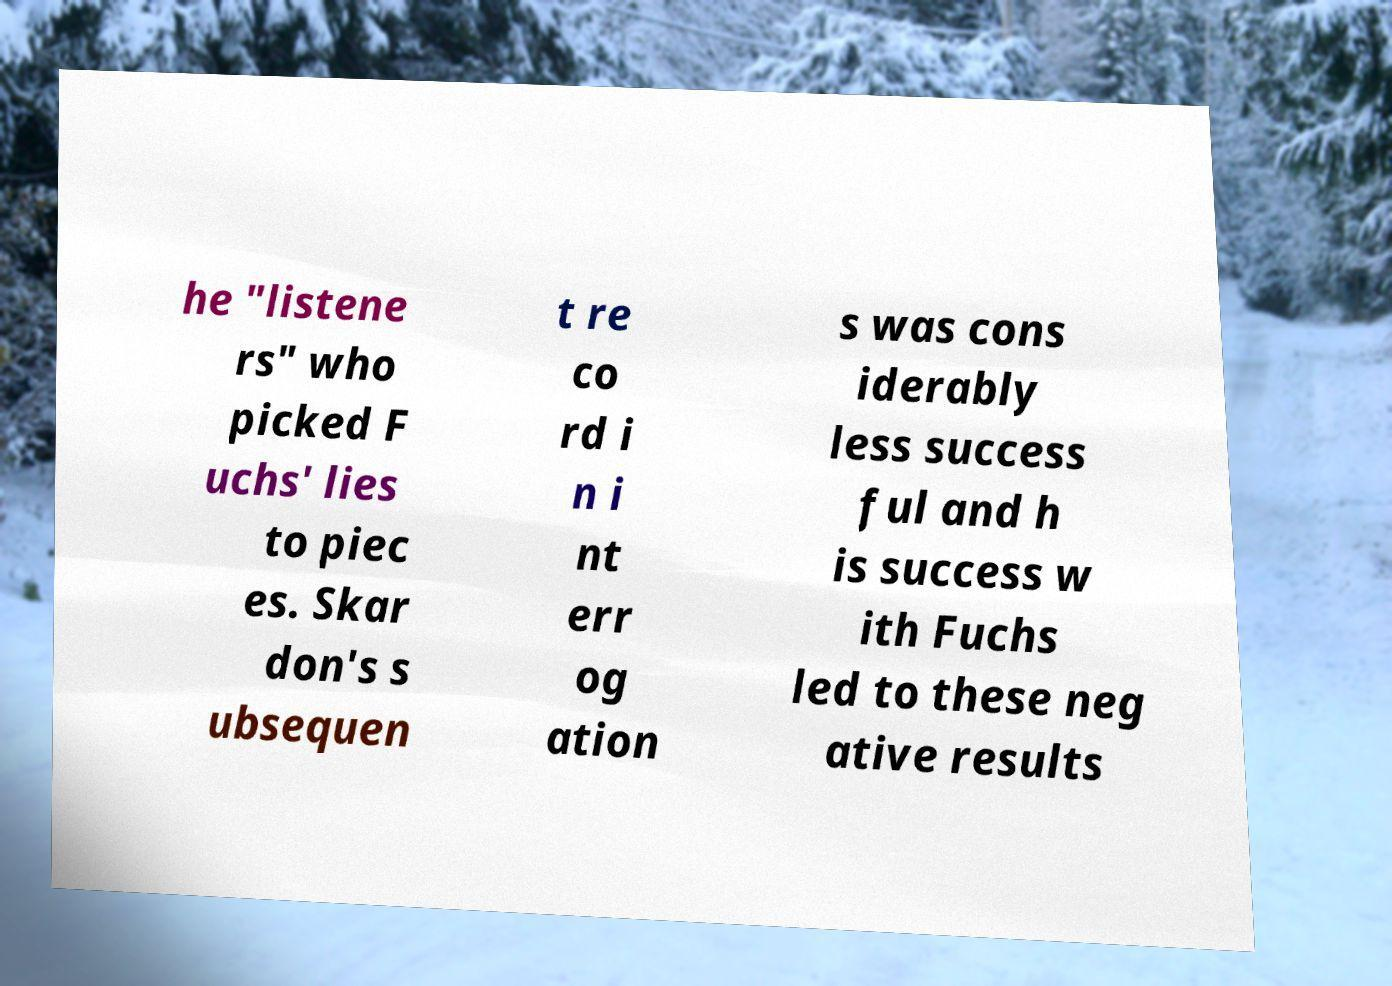Please identify and transcribe the text found in this image. he "listene rs" who picked F uchs' lies to piec es. Skar don's s ubsequen t re co rd i n i nt err og ation s was cons iderably less success ful and h is success w ith Fuchs led to these neg ative results 